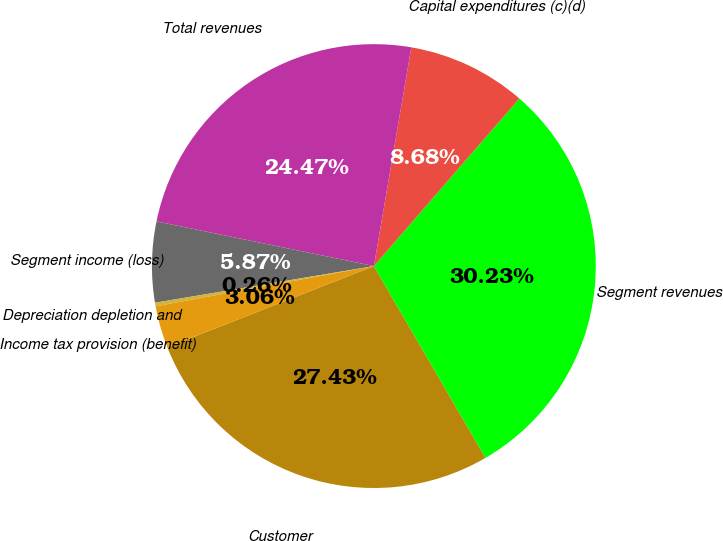Convert chart. <chart><loc_0><loc_0><loc_500><loc_500><pie_chart><fcel>Customer<fcel>Segment revenues<fcel>Capital expenditures (c)(d)<fcel>Total revenues<fcel>Segment income (loss)<fcel>Depreciation depletion and<fcel>Income tax provision (benefit)<nl><fcel>27.43%<fcel>30.23%<fcel>8.68%<fcel>24.47%<fcel>5.87%<fcel>0.26%<fcel>3.06%<nl></chart> 